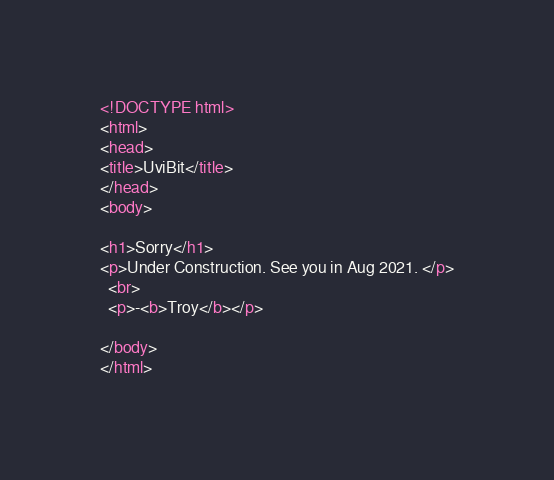Convert code to text. <code><loc_0><loc_0><loc_500><loc_500><_HTML_><!DOCTYPE html>
<html>
<head>
<title>UviBit</title>
</head>
<body>

<h1>Sorry</h1>
<p>Under Construction. See you in Aug 2021. </p>
  <br>
  <p>-<b>Troy</b></p>

</body>
</html>
</code> 